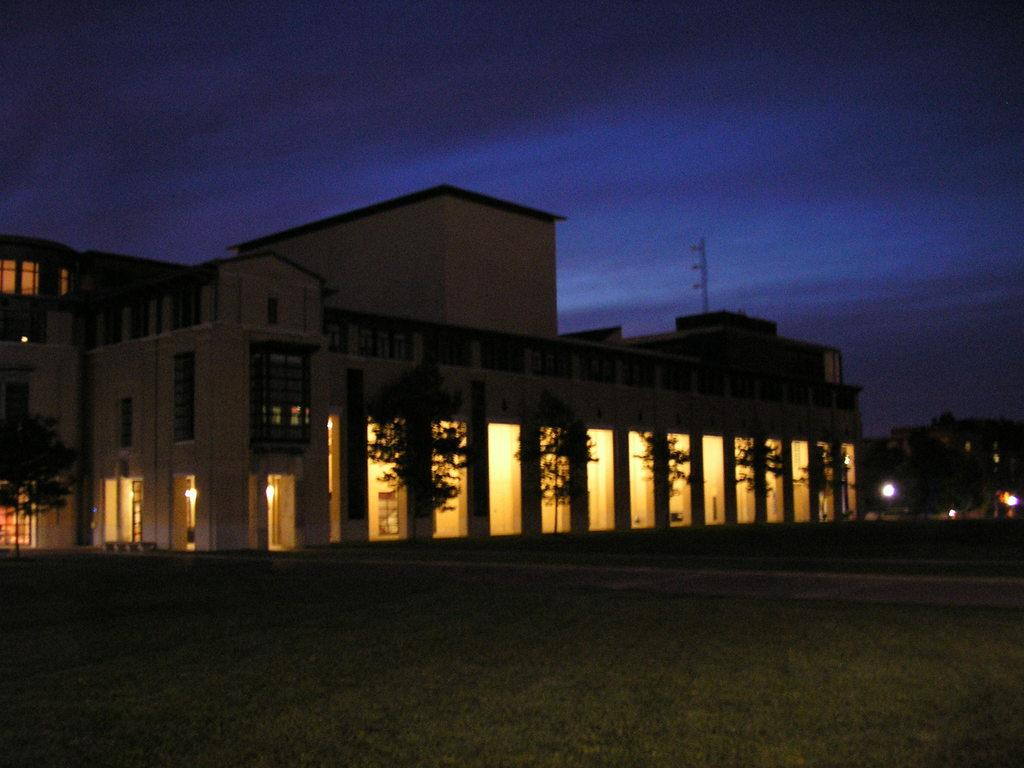What type of ground surface is visible in the image? There is grass on the ground in the image. What type of vegetation is present in the image? There are trees in the image. What type of structures are visible in the image? There are buildings in the image. What type of illumination is present in the image? There are lights in the image. What part of the natural environment is visible in the image? The sky is visible in the image. What type of gold object is visible in the image? There is no gold object present in the image. What type of juice can be seen being poured in the image? There is no juice or pouring action present in the image. 